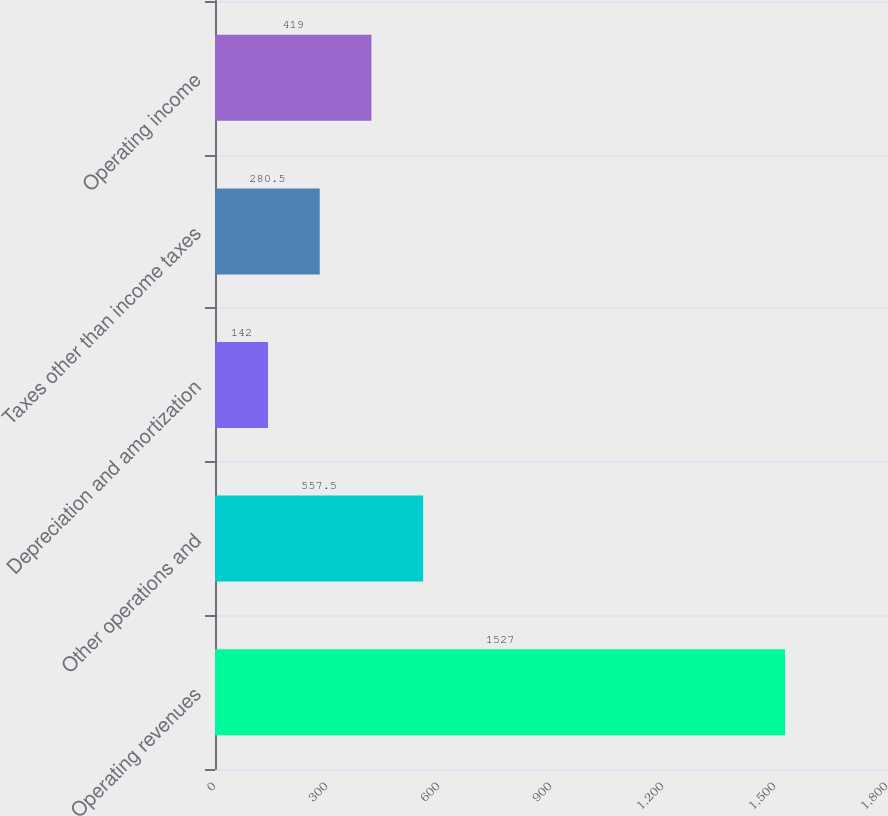Convert chart to OTSL. <chart><loc_0><loc_0><loc_500><loc_500><bar_chart><fcel>Operating revenues<fcel>Other operations and<fcel>Depreciation and amortization<fcel>Taxes other than income taxes<fcel>Operating income<nl><fcel>1527<fcel>557.5<fcel>142<fcel>280.5<fcel>419<nl></chart> 